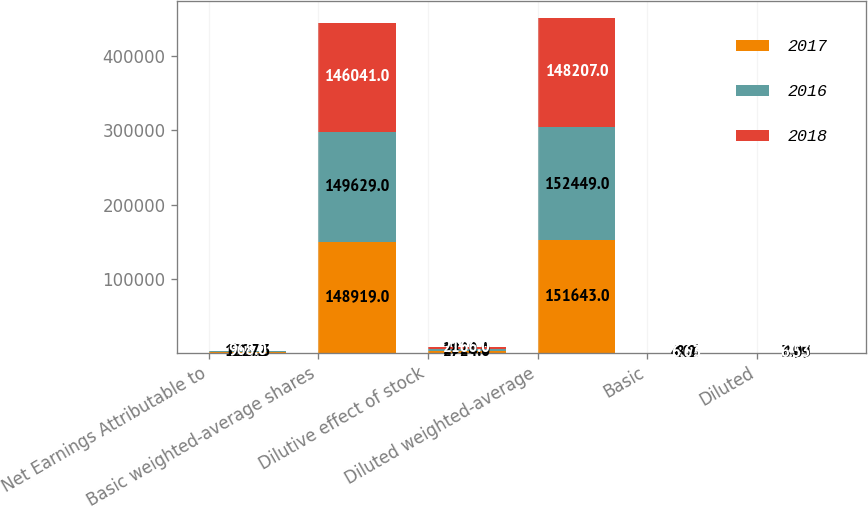Convert chart. <chart><loc_0><loc_0><loc_500><loc_500><stacked_bar_chart><ecel><fcel>Net Earnings Attributable to<fcel>Basic weighted-average shares<fcel>Dilutive effect of stock<fcel>Diluted weighted-average<fcel>Basic<fcel>Diluted<nl><fcel>2017<fcel>605.2<fcel>148919<fcel>2724<fcel>151643<fcel>4.06<fcel>3.99<nl><fcel>2016<fcel>1227.3<fcel>149629<fcel>2820<fcel>152449<fcel>8.2<fcel>8.05<nl><fcel>2018<fcel>968<fcel>146041<fcel>2166<fcel>148207<fcel>6.63<fcel>6.53<nl></chart> 